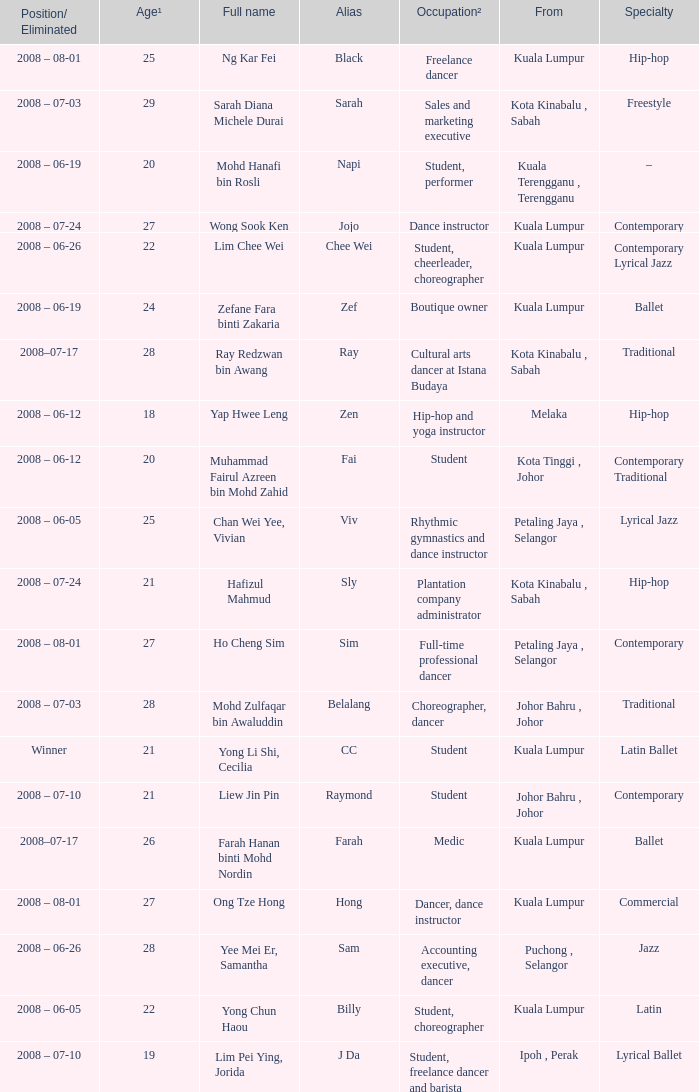What is Occupation², when Age¹ is greater than 24, when Alias is "Black"? Freelance dancer. 